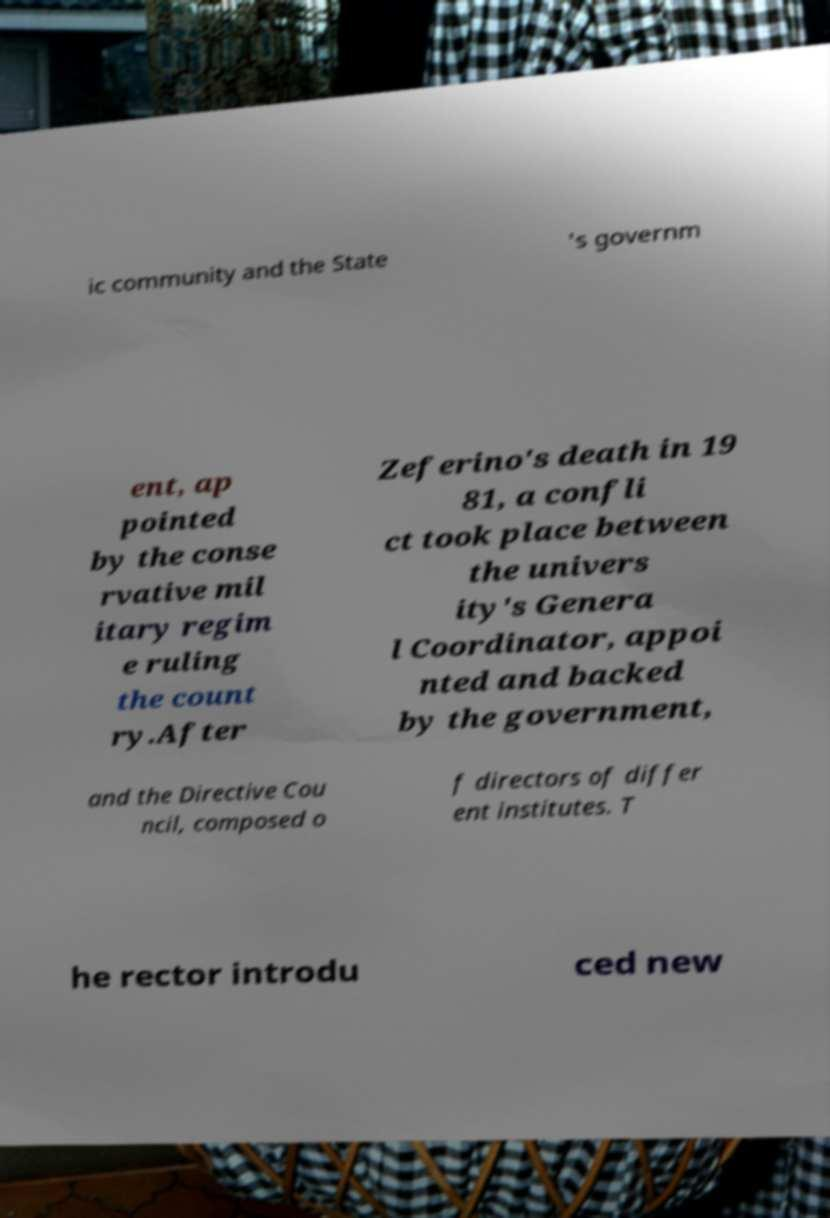I need the written content from this picture converted into text. Can you do that? ic community and the State 's governm ent, ap pointed by the conse rvative mil itary regim e ruling the count ry.After Zeferino's death in 19 81, a confli ct took place between the univers ity's Genera l Coordinator, appoi nted and backed by the government, and the Directive Cou ncil, composed o f directors of differ ent institutes. T he rector introdu ced new 